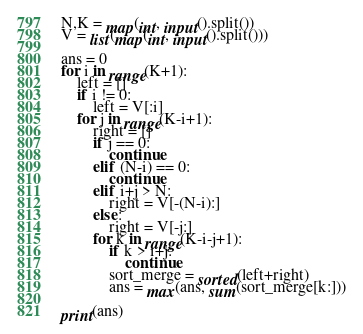Convert code to text. <code><loc_0><loc_0><loc_500><loc_500><_Python_>N,K = map(int, input().split())
V = list(map(int, input().split()))

ans = 0
for i in range(K+1):
    left = []
    if i != 0:
        left = V[:i]
    for j in range(K-i+1):
        right = []
        if j == 0:
            continue
        elif (N-i) == 0:
            continue
        elif i+j > N:
            right = V[-(N-i):]
        else:
            right = V[-j:]
        for k in range(K-i-j+1):
            if k > i+j:
                continue
            sort_merge = sorted(left+right)
            ans = max(ans, sum(sort_merge[k:]))

print(ans)</code> 